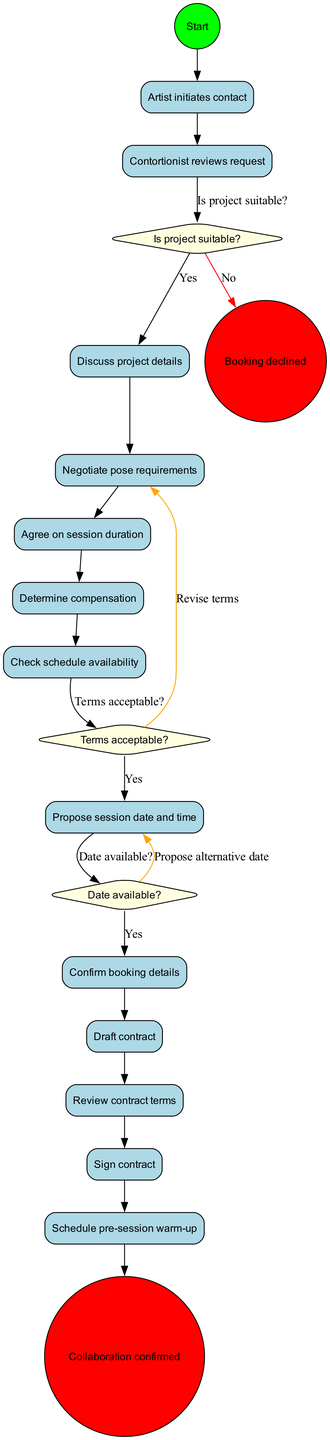What is the starting node of the diagram? The diagram begins with the node labeled "Artist initiates contact". This is the first action that sets the process in motion.
Answer: Artist initiates contact How many activities are listed in the diagram? The diagram contains a total of 11 activities, each detailing a step in the booking process for the collaboration.
Answer: 11 What decision follows the activity "Contortionist reviews request"? After "Contortionist reviews request", the decision made is "Is project suitable?". This decision is critical in determining the next steps.
Answer: Is project suitable? If the terms are not acceptable, what is the next step according to the diagram? If the terms are not acceptable, the next step according to the diagram is to "Revise terms". This indicates a need for further negotiation before proceeding.
Answer: Revise terms What happens if the project is not suitable? If the project is not suitable, the flow will lead to the end node labeled "Booking declined", indicating the cancellation of the booking process.
Answer: Booking declined Which activity occurs right before the contract is signed? The activity that occurs right before the contract is signed is "Review contract terms". This ensures both parties agree before finalizing the contract.
Answer: Review contract terms What decision is made after checking schedule availability? After checking schedule availability, the decision made is "Date available?". This is essential to confirm the timing of the collaboration.
Answer: Date available? What is the final activity in the booking process? The final activity in the booking process is "Schedule pre-session warm-up". This signifies preparations before the actual collaboration takes place.
Answer: Schedule pre-session warm-up What is the consequence of confirming booking details? Confirming booking details leads to the end node "Collaboration confirmed", indicating that both parties have agreed to the terms and the booking is finalized.
Answer: Collaboration confirmed 